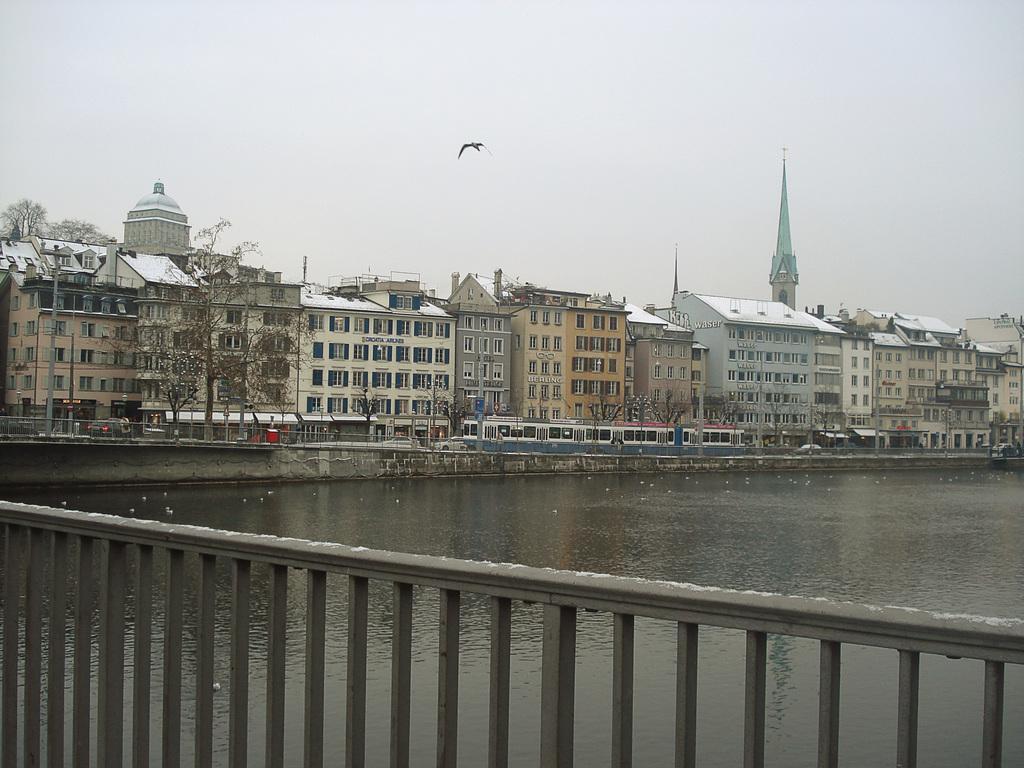Could you give a brief overview of what you see in this image? In this image, we can see water and there is a fencing and there are some buildings, there is a bird flying, at the top there is a sky. 